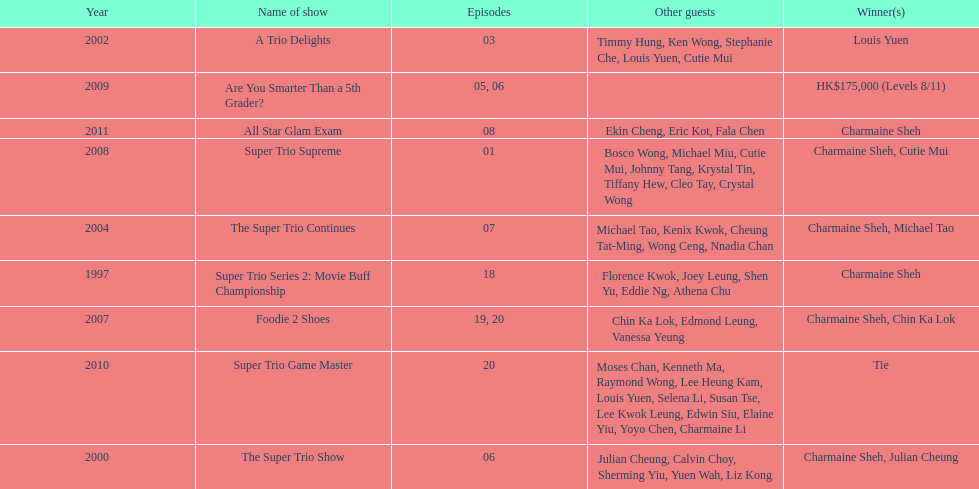What year was the only year were a tie occurred? 2010. Parse the full table. {'header': ['Year', 'Name of show', 'Episodes', 'Other guests', 'Winner(s)'], 'rows': [['2002', 'A Trio Delights', '03', 'Timmy Hung, Ken Wong, Stephanie Che, Louis Yuen, Cutie Mui', 'Louis Yuen'], ['2009', 'Are You Smarter Than a 5th Grader?', '05, 06', '', 'HK$175,000 (Levels 8/11)'], ['2011', 'All Star Glam Exam', '08', 'Ekin Cheng, Eric Kot, Fala Chen', 'Charmaine Sheh'], ['2008', 'Super Trio Supreme', '01', 'Bosco Wong, Michael Miu, Cutie Mui, Johnny Tang, Krystal Tin, Tiffany Hew, Cleo Tay, Crystal Wong', 'Charmaine Sheh, Cutie Mui'], ['2004', 'The Super Trio Continues', '07', 'Michael Tao, Kenix Kwok, Cheung Tat-Ming, Wong Ceng, Nnadia Chan', 'Charmaine Sheh, Michael Tao'], ['1997', 'Super Trio Series 2: Movie Buff Championship', '18', 'Florence Kwok, Joey Leung, Shen Yu, Eddie Ng, Athena Chu', 'Charmaine Sheh'], ['2007', 'Foodie 2 Shoes', '19, 20', 'Chin Ka Lok, Edmond Leung, Vanessa Yeung', 'Charmaine Sheh, Chin Ka Lok'], ['2010', 'Super Trio Game Master', '20', 'Moses Chan, Kenneth Ma, Raymond Wong, Lee Heung Kam, Louis Yuen, Selena Li, Susan Tse, Lee Kwok Leung, Edwin Siu, Elaine Yiu, Yoyo Chen, Charmaine Li', 'Tie'], ['2000', 'The Super Trio Show', '06', 'Julian Cheung, Calvin Choy, Sherming Yiu, Yuen Wah, Liz Kong', 'Charmaine Sheh, Julian Cheung']]} 